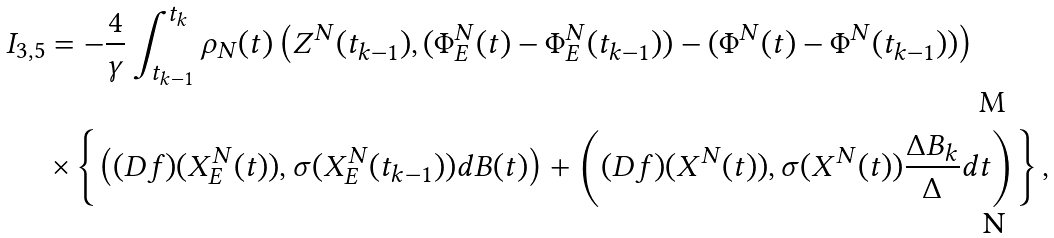Convert formula to latex. <formula><loc_0><loc_0><loc_500><loc_500>I _ { 3 , 5 } & = - \frac { 4 } { \gamma } \int _ { t _ { k - 1 } } ^ { t _ { k } } \rho _ { N } ( t ) \left ( Z ^ { N } ( t _ { k - 1 } ) , ( \Phi ^ { N } _ { E } ( t ) - \Phi ^ { N } _ { E } ( t _ { k - 1 } ) ) - ( \Phi ^ { N } ( t ) - \Phi ^ { N } ( t _ { k - 1 } ) ) \right ) \\ & \times \left \{ \left ( ( D f ) ( X ^ { N } _ { E } ( t ) ) , \sigma ( X ^ { N } _ { E } ( t _ { k - 1 } ) ) d B ( t ) \right ) + \left ( ( D f ) ( X ^ { N } ( t ) ) , \sigma ( X ^ { N } ( t ) ) \frac { \Delta B _ { k } } { \Delta } d t \right ) \right \} ,</formula> 